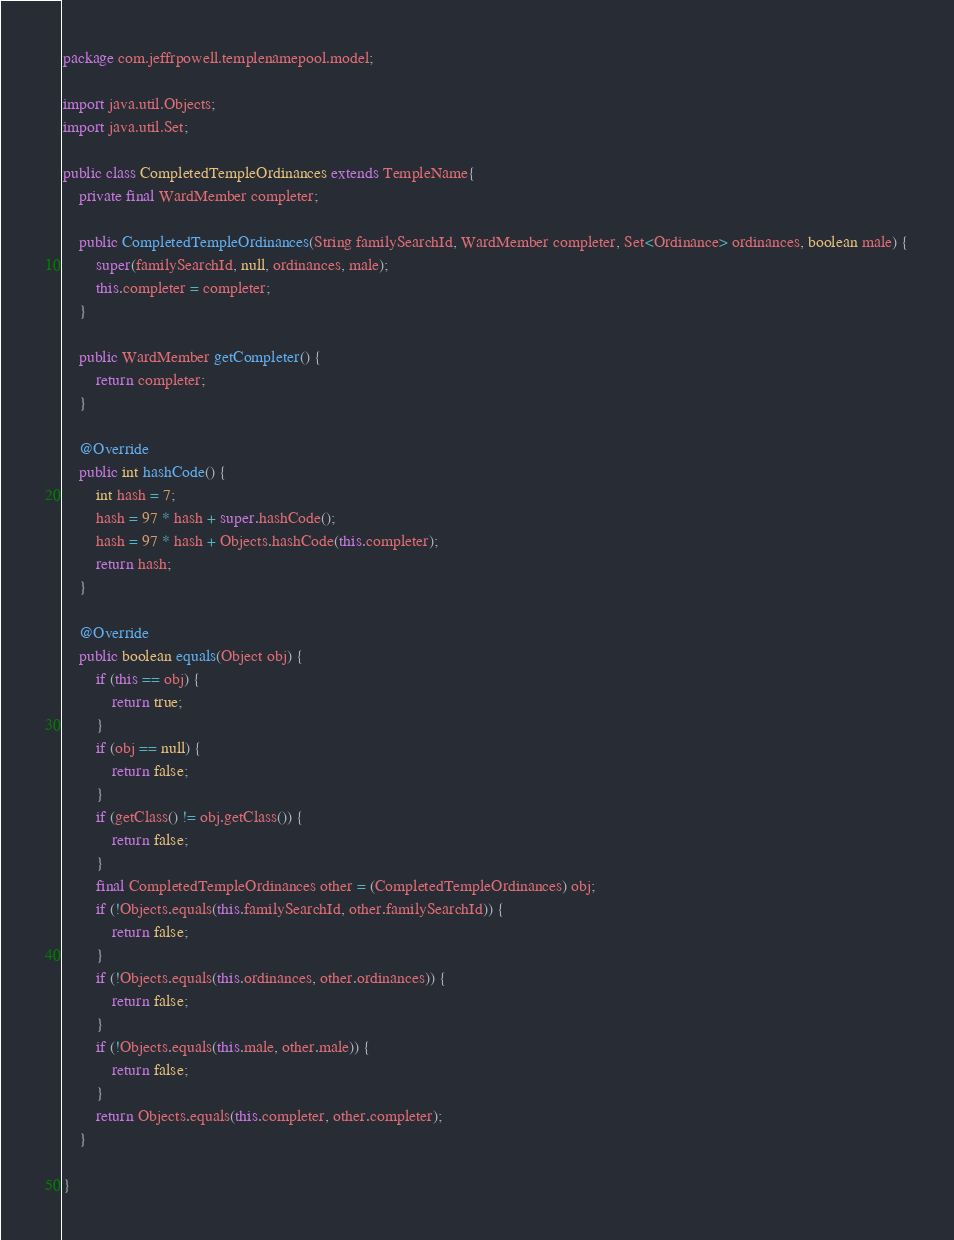Convert code to text. <code><loc_0><loc_0><loc_500><loc_500><_Java_>package com.jeffrpowell.templenamepool.model;

import java.util.Objects;
import java.util.Set;

public class CompletedTempleOrdinances extends TempleName{
    private final WardMember completer;
    
    public CompletedTempleOrdinances(String familySearchId, WardMember completer, Set<Ordinance> ordinances, boolean male) {
        super(familySearchId, null, ordinances, male);
        this.completer = completer;
    }

    public WardMember getCompleter() {
        return completer;
    }

    @Override
    public int hashCode() {
        int hash = 7;
        hash = 97 * hash + super.hashCode();
        hash = 97 * hash + Objects.hashCode(this.completer);
        return hash;
    }

    @Override
    public boolean equals(Object obj) {
        if (this == obj) {
            return true;
        }
        if (obj == null) {
            return false;
        }
        if (getClass() != obj.getClass()) {
            return false;
        }
        final CompletedTempleOrdinances other = (CompletedTempleOrdinances) obj;
        if (!Objects.equals(this.familySearchId, other.familySearchId)) {
            return false;
        }
        if (!Objects.equals(this.ordinances, other.ordinances)) {
            return false;
        }
        if (!Objects.equals(this.male, other.male)) {
            return false;
        }
        return Objects.equals(this.completer, other.completer);
    }
    
}
</code> 